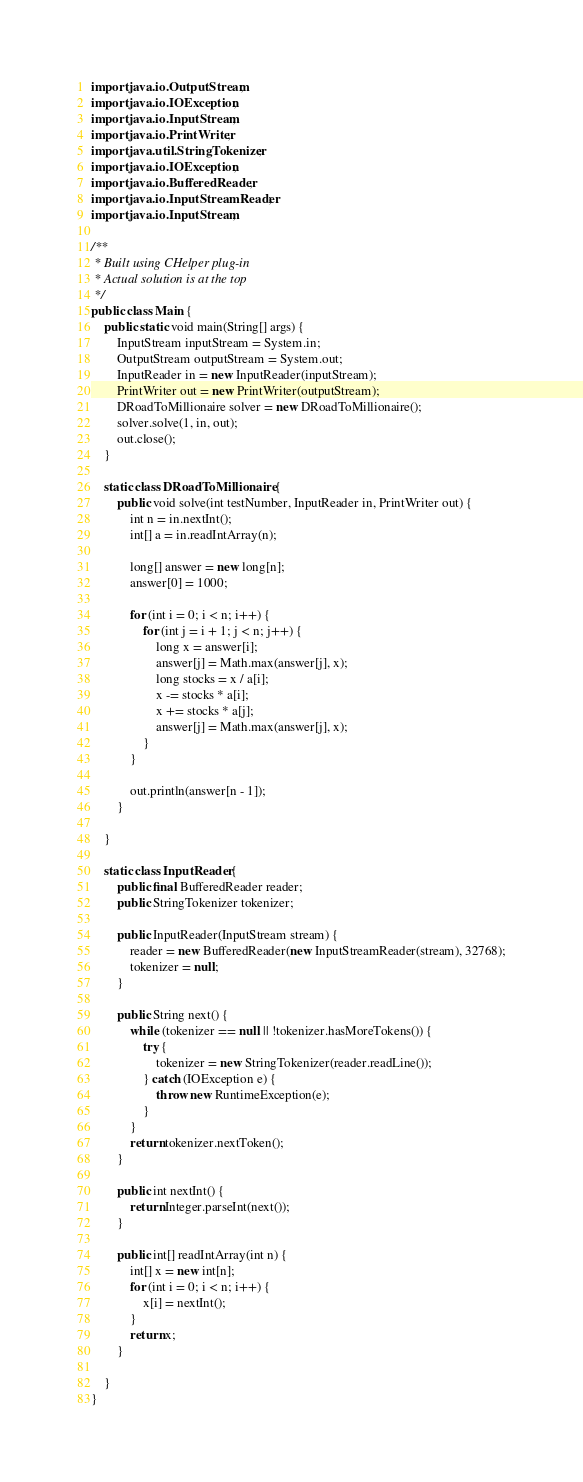Convert code to text. <code><loc_0><loc_0><loc_500><loc_500><_Java_>import java.io.OutputStream;
import java.io.IOException;
import java.io.InputStream;
import java.io.PrintWriter;
import java.util.StringTokenizer;
import java.io.IOException;
import java.io.BufferedReader;
import java.io.InputStreamReader;
import java.io.InputStream;

/**
 * Built using CHelper plug-in
 * Actual solution is at the top
 */
public class Main {
    public static void main(String[] args) {
        InputStream inputStream = System.in;
        OutputStream outputStream = System.out;
        InputReader in = new InputReader(inputStream);
        PrintWriter out = new PrintWriter(outputStream);
        DRoadToMillionaire solver = new DRoadToMillionaire();
        solver.solve(1, in, out);
        out.close();
    }

    static class DRoadToMillionaire {
        public void solve(int testNumber, InputReader in, PrintWriter out) {
            int n = in.nextInt();
            int[] a = in.readIntArray(n);

            long[] answer = new long[n];
            answer[0] = 1000;

            for (int i = 0; i < n; i++) {
                for (int j = i + 1; j < n; j++) {
                    long x = answer[i];
                    answer[j] = Math.max(answer[j], x);
                    long stocks = x / a[i];
                    x -= stocks * a[i];
                    x += stocks * a[j];
                    answer[j] = Math.max(answer[j], x);
                }
            }

            out.println(answer[n - 1]);
        }

    }

    static class InputReader {
        public final BufferedReader reader;
        public StringTokenizer tokenizer;

        public InputReader(InputStream stream) {
            reader = new BufferedReader(new InputStreamReader(stream), 32768);
            tokenizer = null;
        }

        public String next() {
            while (tokenizer == null || !tokenizer.hasMoreTokens()) {
                try {
                    tokenizer = new StringTokenizer(reader.readLine());
                } catch (IOException e) {
                    throw new RuntimeException(e);
                }
            }
            return tokenizer.nextToken();
        }

        public int nextInt() {
            return Integer.parseInt(next());
        }

        public int[] readIntArray(int n) {
            int[] x = new int[n];
            for (int i = 0; i < n; i++) {
                x[i] = nextInt();
            }
            return x;
        }

    }
}

</code> 